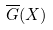Convert formula to latex. <formula><loc_0><loc_0><loc_500><loc_500>\overline { G } ( X )</formula> 